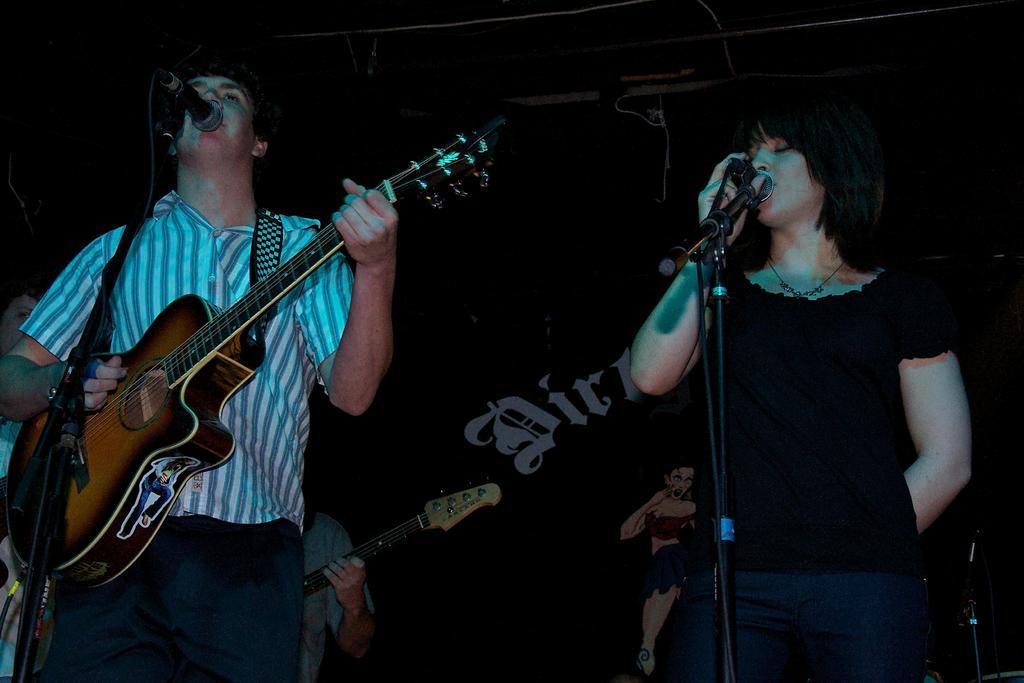In one or two sentences, can you explain what this image depicts? In this picture is a woman and a man singing in the microphone the man is playing the guitar 